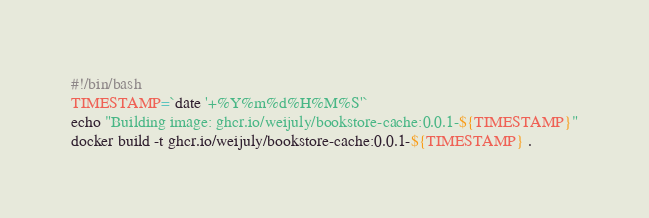Convert code to text. <code><loc_0><loc_0><loc_500><loc_500><_Bash_>#!/bin/bash
TIMESTAMP=`date '+%Y%m%d%H%M%S'`
echo "Building image: ghcr.io/weijuly/bookstore-cache:0.0.1-${TIMESTAMP}"
docker build -t ghcr.io/weijuly/bookstore-cache:0.0.1-${TIMESTAMP} .
</code> 